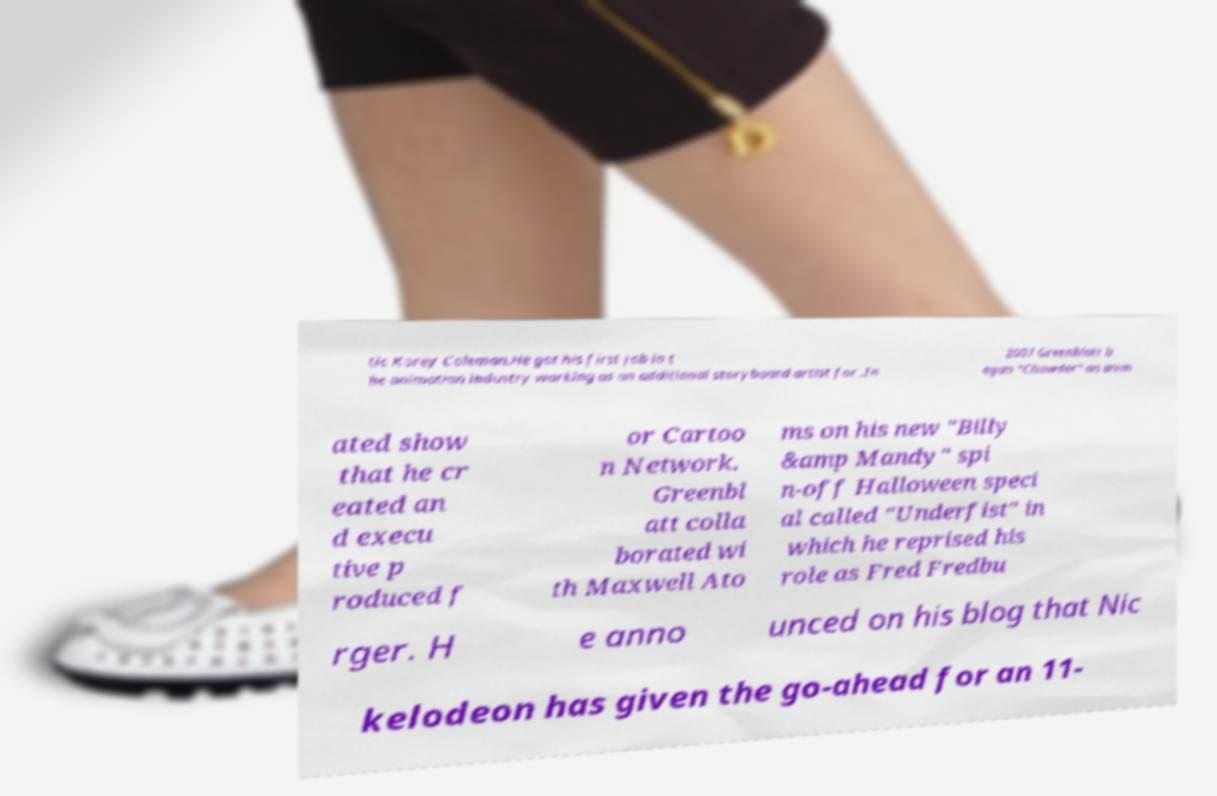Can you read and provide the text displayed in the image?This photo seems to have some interesting text. Can you extract and type it out for me? tic Korey Coleman.He got his first job in t he animation industry working as an additional storyboard artist for .In 2007 Greenblatt b egan "Chowder" an anim ated show that he cr eated an d execu tive p roduced f or Cartoo n Network. Greenbl att colla borated wi th Maxwell Ato ms on his new "Billy &amp Mandy" spi n-off Halloween speci al called "Underfist" in which he reprised his role as Fred Fredbu rger. H e anno unced on his blog that Nic kelodeon has given the go-ahead for an 11- 